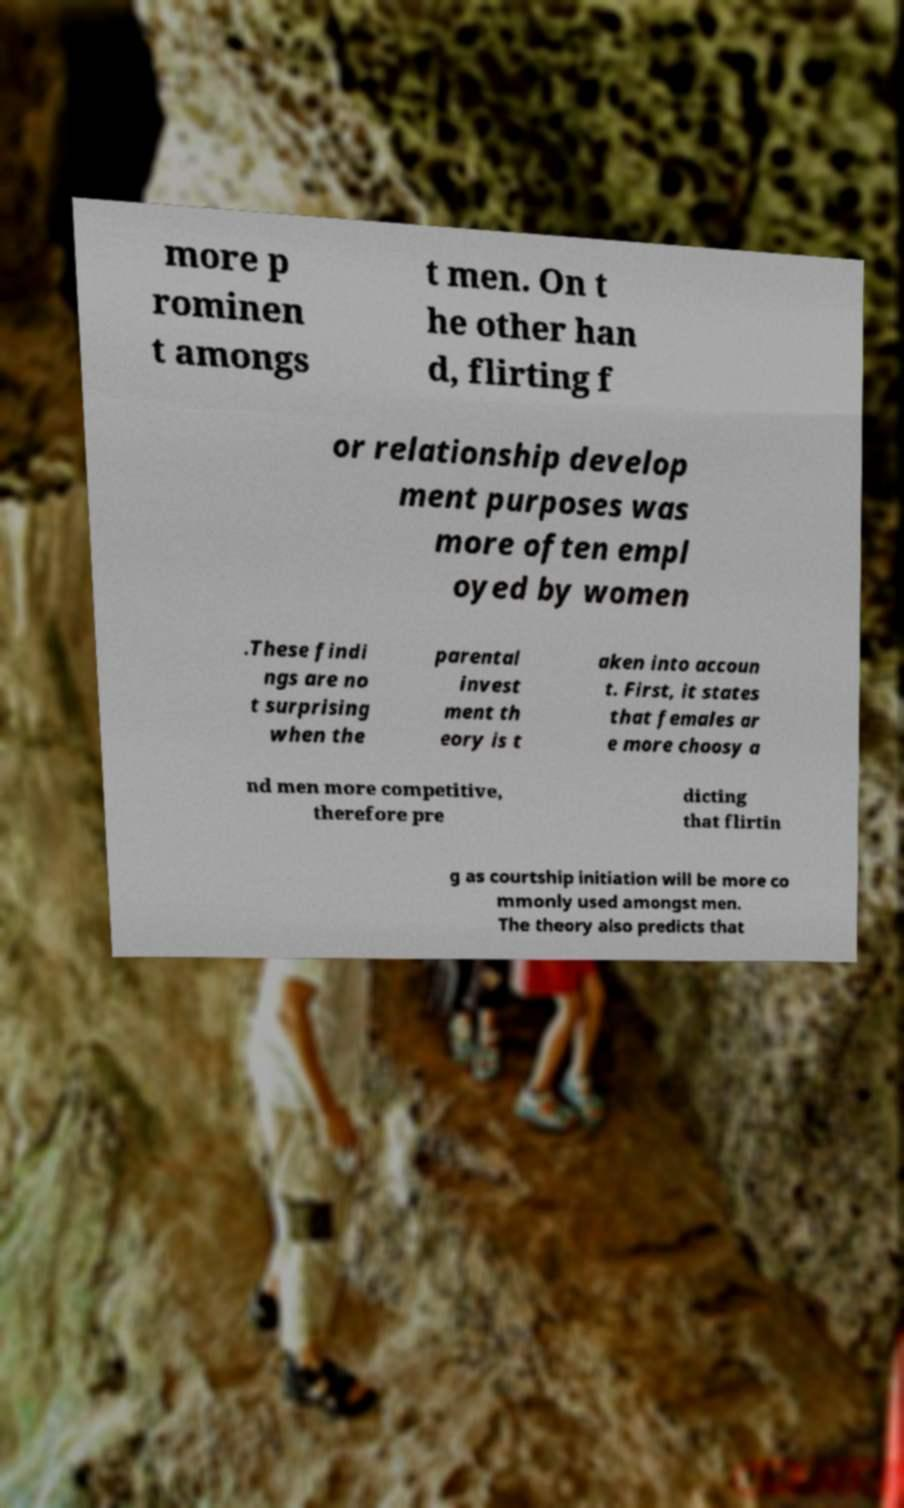Please read and relay the text visible in this image. What does it say? more p rominen t amongs t men. On t he other han d, flirting f or relationship develop ment purposes was more often empl oyed by women .These findi ngs are no t surprising when the parental invest ment th eory is t aken into accoun t. First, it states that females ar e more choosy a nd men more competitive, therefore pre dicting that flirtin g as courtship initiation will be more co mmonly used amongst men. The theory also predicts that 